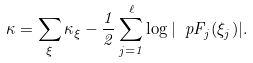Convert formula to latex. <formula><loc_0><loc_0><loc_500><loc_500>\kappa = \sum _ { \xi } \kappa _ { \xi } - \frac { 1 } { 2 } \sum _ { j = 1 } ^ { \ell } \log | \ p F _ { j } ( \xi _ { j } ) | .</formula> 